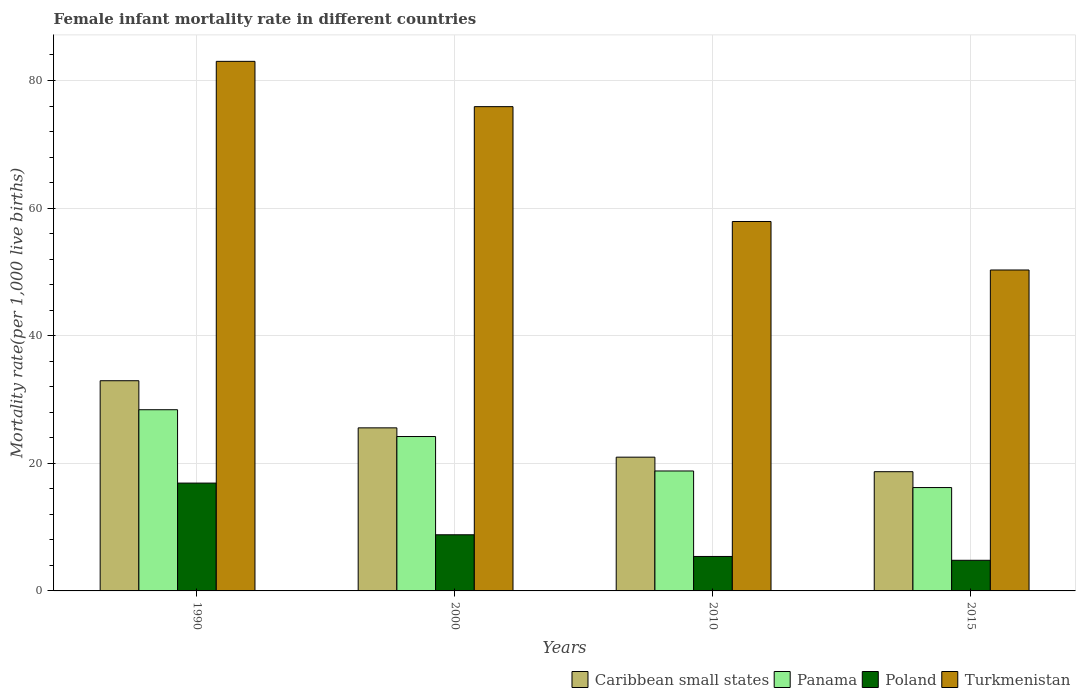How many groups of bars are there?
Offer a terse response. 4. Are the number of bars per tick equal to the number of legend labels?
Give a very brief answer. Yes. Are the number of bars on each tick of the X-axis equal?
Ensure brevity in your answer.  Yes. How many bars are there on the 4th tick from the left?
Your response must be concise. 4. How many bars are there on the 3rd tick from the right?
Provide a short and direct response. 4. What is the female infant mortality rate in Caribbean small states in 2010?
Your answer should be compact. 20.96. Across all years, what is the maximum female infant mortality rate in Caribbean small states?
Your response must be concise. 32.95. Across all years, what is the minimum female infant mortality rate in Caribbean small states?
Give a very brief answer. 18.69. In which year was the female infant mortality rate in Caribbean small states maximum?
Make the answer very short. 1990. In which year was the female infant mortality rate in Panama minimum?
Give a very brief answer. 2015. What is the total female infant mortality rate in Panama in the graph?
Provide a short and direct response. 87.6. What is the difference between the female infant mortality rate in Poland in 1990 and that in 2010?
Give a very brief answer. 11.5. What is the difference between the female infant mortality rate in Turkmenistan in 2010 and the female infant mortality rate in Caribbean small states in 2015?
Make the answer very short. 39.21. What is the average female infant mortality rate in Poland per year?
Provide a succinct answer. 8.97. In the year 2000, what is the difference between the female infant mortality rate in Panama and female infant mortality rate in Turkmenistan?
Offer a very short reply. -51.7. What is the ratio of the female infant mortality rate in Caribbean small states in 2000 to that in 2010?
Your answer should be compact. 1.22. What is the difference between the highest and the second highest female infant mortality rate in Poland?
Your answer should be very brief. 8.1. What is the difference between the highest and the lowest female infant mortality rate in Turkmenistan?
Keep it short and to the point. 32.7. Is the sum of the female infant mortality rate in Caribbean small states in 1990 and 2015 greater than the maximum female infant mortality rate in Panama across all years?
Provide a short and direct response. Yes. Is it the case that in every year, the sum of the female infant mortality rate in Poland and female infant mortality rate in Panama is greater than the sum of female infant mortality rate in Turkmenistan and female infant mortality rate in Caribbean small states?
Offer a very short reply. No. What does the 2nd bar from the left in 2000 represents?
Provide a succinct answer. Panama. Is it the case that in every year, the sum of the female infant mortality rate in Poland and female infant mortality rate in Turkmenistan is greater than the female infant mortality rate in Panama?
Your answer should be compact. Yes. How many bars are there?
Give a very brief answer. 16. How many years are there in the graph?
Your response must be concise. 4. Are the values on the major ticks of Y-axis written in scientific E-notation?
Provide a succinct answer. No. Does the graph contain grids?
Give a very brief answer. Yes. Where does the legend appear in the graph?
Give a very brief answer. Bottom right. How many legend labels are there?
Provide a short and direct response. 4. What is the title of the graph?
Give a very brief answer. Female infant mortality rate in different countries. Does "Lao PDR" appear as one of the legend labels in the graph?
Offer a terse response. No. What is the label or title of the Y-axis?
Keep it short and to the point. Mortality rate(per 1,0 live births). What is the Mortality rate(per 1,000 live births) in Caribbean small states in 1990?
Your response must be concise. 32.95. What is the Mortality rate(per 1,000 live births) in Panama in 1990?
Your answer should be compact. 28.4. What is the Mortality rate(per 1,000 live births) in Caribbean small states in 2000?
Make the answer very short. 25.56. What is the Mortality rate(per 1,000 live births) in Panama in 2000?
Give a very brief answer. 24.2. What is the Mortality rate(per 1,000 live births) in Turkmenistan in 2000?
Offer a very short reply. 75.9. What is the Mortality rate(per 1,000 live births) of Caribbean small states in 2010?
Provide a succinct answer. 20.96. What is the Mortality rate(per 1,000 live births) in Poland in 2010?
Ensure brevity in your answer.  5.4. What is the Mortality rate(per 1,000 live births) of Turkmenistan in 2010?
Offer a terse response. 57.9. What is the Mortality rate(per 1,000 live births) of Caribbean small states in 2015?
Ensure brevity in your answer.  18.69. What is the Mortality rate(per 1,000 live births) of Poland in 2015?
Ensure brevity in your answer.  4.8. What is the Mortality rate(per 1,000 live births) in Turkmenistan in 2015?
Ensure brevity in your answer.  50.3. Across all years, what is the maximum Mortality rate(per 1,000 live births) of Caribbean small states?
Give a very brief answer. 32.95. Across all years, what is the maximum Mortality rate(per 1,000 live births) in Panama?
Your response must be concise. 28.4. Across all years, what is the maximum Mortality rate(per 1,000 live births) of Poland?
Ensure brevity in your answer.  16.9. Across all years, what is the maximum Mortality rate(per 1,000 live births) of Turkmenistan?
Your answer should be compact. 83. Across all years, what is the minimum Mortality rate(per 1,000 live births) in Caribbean small states?
Keep it short and to the point. 18.69. Across all years, what is the minimum Mortality rate(per 1,000 live births) of Panama?
Offer a terse response. 16.2. Across all years, what is the minimum Mortality rate(per 1,000 live births) in Poland?
Your answer should be compact. 4.8. Across all years, what is the minimum Mortality rate(per 1,000 live births) of Turkmenistan?
Give a very brief answer. 50.3. What is the total Mortality rate(per 1,000 live births) in Caribbean small states in the graph?
Give a very brief answer. 98.15. What is the total Mortality rate(per 1,000 live births) of Panama in the graph?
Make the answer very short. 87.6. What is the total Mortality rate(per 1,000 live births) in Poland in the graph?
Give a very brief answer. 35.9. What is the total Mortality rate(per 1,000 live births) in Turkmenistan in the graph?
Ensure brevity in your answer.  267.1. What is the difference between the Mortality rate(per 1,000 live births) of Caribbean small states in 1990 and that in 2000?
Ensure brevity in your answer.  7.39. What is the difference between the Mortality rate(per 1,000 live births) in Poland in 1990 and that in 2000?
Provide a short and direct response. 8.1. What is the difference between the Mortality rate(per 1,000 live births) in Caribbean small states in 1990 and that in 2010?
Provide a short and direct response. 11.98. What is the difference between the Mortality rate(per 1,000 live births) in Turkmenistan in 1990 and that in 2010?
Your answer should be very brief. 25.1. What is the difference between the Mortality rate(per 1,000 live births) of Caribbean small states in 1990 and that in 2015?
Your answer should be compact. 14.26. What is the difference between the Mortality rate(per 1,000 live births) of Turkmenistan in 1990 and that in 2015?
Your response must be concise. 32.7. What is the difference between the Mortality rate(per 1,000 live births) in Caribbean small states in 2000 and that in 2010?
Your answer should be very brief. 4.59. What is the difference between the Mortality rate(per 1,000 live births) of Poland in 2000 and that in 2010?
Offer a terse response. 3.4. What is the difference between the Mortality rate(per 1,000 live births) of Turkmenistan in 2000 and that in 2010?
Give a very brief answer. 18. What is the difference between the Mortality rate(per 1,000 live births) of Caribbean small states in 2000 and that in 2015?
Give a very brief answer. 6.87. What is the difference between the Mortality rate(per 1,000 live births) of Panama in 2000 and that in 2015?
Give a very brief answer. 8. What is the difference between the Mortality rate(per 1,000 live births) of Poland in 2000 and that in 2015?
Provide a short and direct response. 4. What is the difference between the Mortality rate(per 1,000 live births) of Turkmenistan in 2000 and that in 2015?
Give a very brief answer. 25.6. What is the difference between the Mortality rate(per 1,000 live births) of Caribbean small states in 2010 and that in 2015?
Make the answer very short. 2.28. What is the difference between the Mortality rate(per 1,000 live births) of Panama in 2010 and that in 2015?
Your answer should be compact. 2.6. What is the difference between the Mortality rate(per 1,000 live births) of Poland in 2010 and that in 2015?
Ensure brevity in your answer.  0.6. What is the difference between the Mortality rate(per 1,000 live births) in Caribbean small states in 1990 and the Mortality rate(per 1,000 live births) in Panama in 2000?
Provide a short and direct response. 8.75. What is the difference between the Mortality rate(per 1,000 live births) in Caribbean small states in 1990 and the Mortality rate(per 1,000 live births) in Poland in 2000?
Offer a very short reply. 24.15. What is the difference between the Mortality rate(per 1,000 live births) in Caribbean small states in 1990 and the Mortality rate(per 1,000 live births) in Turkmenistan in 2000?
Offer a very short reply. -42.95. What is the difference between the Mortality rate(per 1,000 live births) in Panama in 1990 and the Mortality rate(per 1,000 live births) in Poland in 2000?
Offer a very short reply. 19.6. What is the difference between the Mortality rate(per 1,000 live births) of Panama in 1990 and the Mortality rate(per 1,000 live births) of Turkmenistan in 2000?
Ensure brevity in your answer.  -47.5. What is the difference between the Mortality rate(per 1,000 live births) of Poland in 1990 and the Mortality rate(per 1,000 live births) of Turkmenistan in 2000?
Offer a very short reply. -59. What is the difference between the Mortality rate(per 1,000 live births) of Caribbean small states in 1990 and the Mortality rate(per 1,000 live births) of Panama in 2010?
Ensure brevity in your answer.  14.15. What is the difference between the Mortality rate(per 1,000 live births) of Caribbean small states in 1990 and the Mortality rate(per 1,000 live births) of Poland in 2010?
Offer a terse response. 27.55. What is the difference between the Mortality rate(per 1,000 live births) of Caribbean small states in 1990 and the Mortality rate(per 1,000 live births) of Turkmenistan in 2010?
Your answer should be very brief. -24.95. What is the difference between the Mortality rate(per 1,000 live births) in Panama in 1990 and the Mortality rate(per 1,000 live births) in Poland in 2010?
Offer a very short reply. 23. What is the difference between the Mortality rate(per 1,000 live births) of Panama in 1990 and the Mortality rate(per 1,000 live births) of Turkmenistan in 2010?
Your answer should be compact. -29.5. What is the difference between the Mortality rate(per 1,000 live births) of Poland in 1990 and the Mortality rate(per 1,000 live births) of Turkmenistan in 2010?
Ensure brevity in your answer.  -41. What is the difference between the Mortality rate(per 1,000 live births) in Caribbean small states in 1990 and the Mortality rate(per 1,000 live births) in Panama in 2015?
Offer a very short reply. 16.75. What is the difference between the Mortality rate(per 1,000 live births) in Caribbean small states in 1990 and the Mortality rate(per 1,000 live births) in Poland in 2015?
Provide a succinct answer. 28.15. What is the difference between the Mortality rate(per 1,000 live births) of Caribbean small states in 1990 and the Mortality rate(per 1,000 live births) of Turkmenistan in 2015?
Your answer should be compact. -17.35. What is the difference between the Mortality rate(per 1,000 live births) of Panama in 1990 and the Mortality rate(per 1,000 live births) of Poland in 2015?
Keep it short and to the point. 23.6. What is the difference between the Mortality rate(per 1,000 live births) in Panama in 1990 and the Mortality rate(per 1,000 live births) in Turkmenistan in 2015?
Your response must be concise. -21.9. What is the difference between the Mortality rate(per 1,000 live births) in Poland in 1990 and the Mortality rate(per 1,000 live births) in Turkmenistan in 2015?
Your response must be concise. -33.4. What is the difference between the Mortality rate(per 1,000 live births) of Caribbean small states in 2000 and the Mortality rate(per 1,000 live births) of Panama in 2010?
Ensure brevity in your answer.  6.76. What is the difference between the Mortality rate(per 1,000 live births) in Caribbean small states in 2000 and the Mortality rate(per 1,000 live births) in Poland in 2010?
Your response must be concise. 20.16. What is the difference between the Mortality rate(per 1,000 live births) in Caribbean small states in 2000 and the Mortality rate(per 1,000 live births) in Turkmenistan in 2010?
Keep it short and to the point. -32.34. What is the difference between the Mortality rate(per 1,000 live births) in Panama in 2000 and the Mortality rate(per 1,000 live births) in Poland in 2010?
Give a very brief answer. 18.8. What is the difference between the Mortality rate(per 1,000 live births) in Panama in 2000 and the Mortality rate(per 1,000 live births) in Turkmenistan in 2010?
Make the answer very short. -33.7. What is the difference between the Mortality rate(per 1,000 live births) in Poland in 2000 and the Mortality rate(per 1,000 live births) in Turkmenistan in 2010?
Ensure brevity in your answer.  -49.1. What is the difference between the Mortality rate(per 1,000 live births) in Caribbean small states in 2000 and the Mortality rate(per 1,000 live births) in Panama in 2015?
Your answer should be compact. 9.36. What is the difference between the Mortality rate(per 1,000 live births) of Caribbean small states in 2000 and the Mortality rate(per 1,000 live births) of Poland in 2015?
Make the answer very short. 20.76. What is the difference between the Mortality rate(per 1,000 live births) in Caribbean small states in 2000 and the Mortality rate(per 1,000 live births) in Turkmenistan in 2015?
Make the answer very short. -24.74. What is the difference between the Mortality rate(per 1,000 live births) of Panama in 2000 and the Mortality rate(per 1,000 live births) of Turkmenistan in 2015?
Offer a terse response. -26.1. What is the difference between the Mortality rate(per 1,000 live births) in Poland in 2000 and the Mortality rate(per 1,000 live births) in Turkmenistan in 2015?
Make the answer very short. -41.5. What is the difference between the Mortality rate(per 1,000 live births) of Caribbean small states in 2010 and the Mortality rate(per 1,000 live births) of Panama in 2015?
Your answer should be very brief. 4.76. What is the difference between the Mortality rate(per 1,000 live births) in Caribbean small states in 2010 and the Mortality rate(per 1,000 live births) in Poland in 2015?
Give a very brief answer. 16.16. What is the difference between the Mortality rate(per 1,000 live births) of Caribbean small states in 2010 and the Mortality rate(per 1,000 live births) of Turkmenistan in 2015?
Your answer should be compact. -29.34. What is the difference between the Mortality rate(per 1,000 live births) in Panama in 2010 and the Mortality rate(per 1,000 live births) in Turkmenistan in 2015?
Make the answer very short. -31.5. What is the difference between the Mortality rate(per 1,000 live births) in Poland in 2010 and the Mortality rate(per 1,000 live births) in Turkmenistan in 2015?
Provide a short and direct response. -44.9. What is the average Mortality rate(per 1,000 live births) of Caribbean small states per year?
Make the answer very short. 24.54. What is the average Mortality rate(per 1,000 live births) of Panama per year?
Offer a very short reply. 21.9. What is the average Mortality rate(per 1,000 live births) of Poland per year?
Your answer should be compact. 8.97. What is the average Mortality rate(per 1,000 live births) in Turkmenistan per year?
Keep it short and to the point. 66.78. In the year 1990, what is the difference between the Mortality rate(per 1,000 live births) of Caribbean small states and Mortality rate(per 1,000 live births) of Panama?
Keep it short and to the point. 4.55. In the year 1990, what is the difference between the Mortality rate(per 1,000 live births) of Caribbean small states and Mortality rate(per 1,000 live births) of Poland?
Ensure brevity in your answer.  16.05. In the year 1990, what is the difference between the Mortality rate(per 1,000 live births) of Caribbean small states and Mortality rate(per 1,000 live births) of Turkmenistan?
Keep it short and to the point. -50.05. In the year 1990, what is the difference between the Mortality rate(per 1,000 live births) of Panama and Mortality rate(per 1,000 live births) of Turkmenistan?
Give a very brief answer. -54.6. In the year 1990, what is the difference between the Mortality rate(per 1,000 live births) of Poland and Mortality rate(per 1,000 live births) of Turkmenistan?
Your response must be concise. -66.1. In the year 2000, what is the difference between the Mortality rate(per 1,000 live births) in Caribbean small states and Mortality rate(per 1,000 live births) in Panama?
Offer a very short reply. 1.36. In the year 2000, what is the difference between the Mortality rate(per 1,000 live births) in Caribbean small states and Mortality rate(per 1,000 live births) in Poland?
Make the answer very short. 16.76. In the year 2000, what is the difference between the Mortality rate(per 1,000 live births) in Caribbean small states and Mortality rate(per 1,000 live births) in Turkmenistan?
Provide a short and direct response. -50.34. In the year 2000, what is the difference between the Mortality rate(per 1,000 live births) in Panama and Mortality rate(per 1,000 live births) in Turkmenistan?
Your response must be concise. -51.7. In the year 2000, what is the difference between the Mortality rate(per 1,000 live births) of Poland and Mortality rate(per 1,000 live births) of Turkmenistan?
Make the answer very short. -67.1. In the year 2010, what is the difference between the Mortality rate(per 1,000 live births) in Caribbean small states and Mortality rate(per 1,000 live births) in Panama?
Make the answer very short. 2.16. In the year 2010, what is the difference between the Mortality rate(per 1,000 live births) in Caribbean small states and Mortality rate(per 1,000 live births) in Poland?
Keep it short and to the point. 15.56. In the year 2010, what is the difference between the Mortality rate(per 1,000 live births) in Caribbean small states and Mortality rate(per 1,000 live births) in Turkmenistan?
Keep it short and to the point. -36.94. In the year 2010, what is the difference between the Mortality rate(per 1,000 live births) of Panama and Mortality rate(per 1,000 live births) of Turkmenistan?
Ensure brevity in your answer.  -39.1. In the year 2010, what is the difference between the Mortality rate(per 1,000 live births) in Poland and Mortality rate(per 1,000 live births) in Turkmenistan?
Offer a very short reply. -52.5. In the year 2015, what is the difference between the Mortality rate(per 1,000 live births) in Caribbean small states and Mortality rate(per 1,000 live births) in Panama?
Offer a very short reply. 2.49. In the year 2015, what is the difference between the Mortality rate(per 1,000 live births) in Caribbean small states and Mortality rate(per 1,000 live births) in Poland?
Provide a succinct answer. 13.89. In the year 2015, what is the difference between the Mortality rate(per 1,000 live births) of Caribbean small states and Mortality rate(per 1,000 live births) of Turkmenistan?
Your answer should be compact. -31.61. In the year 2015, what is the difference between the Mortality rate(per 1,000 live births) in Panama and Mortality rate(per 1,000 live births) in Poland?
Your response must be concise. 11.4. In the year 2015, what is the difference between the Mortality rate(per 1,000 live births) of Panama and Mortality rate(per 1,000 live births) of Turkmenistan?
Give a very brief answer. -34.1. In the year 2015, what is the difference between the Mortality rate(per 1,000 live births) in Poland and Mortality rate(per 1,000 live births) in Turkmenistan?
Provide a short and direct response. -45.5. What is the ratio of the Mortality rate(per 1,000 live births) in Caribbean small states in 1990 to that in 2000?
Provide a short and direct response. 1.29. What is the ratio of the Mortality rate(per 1,000 live births) of Panama in 1990 to that in 2000?
Offer a very short reply. 1.17. What is the ratio of the Mortality rate(per 1,000 live births) of Poland in 1990 to that in 2000?
Give a very brief answer. 1.92. What is the ratio of the Mortality rate(per 1,000 live births) of Turkmenistan in 1990 to that in 2000?
Your answer should be very brief. 1.09. What is the ratio of the Mortality rate(per 1,000 live births) in Caribbean small states in 1990 to that in 2010?
Your response must be concise. 1.57. What is the ratio of the Mortality rate(per 1,000 live births) in Panama in 1990 to that in 2010?
Your response must be concise. 1.51. What is the ratio of the Mortality rate(per 1,000 live births) in Poland in 1990 to that in 2010?
Ensure brevity in your answer.  3.13. What is the ratio of the Mortality rate(per 1,000 live births) in Turkmenistan in 1990 to that in 2010?
Your answer should be very brief. 1.43. What is the ratio of the Mortality rate(per 1,000 live births) of Caribbean small states in 1990 to that in 2015?
Your response must be concise. 1.76. What is the ratio of the Mortality rate(per 1,000 live births) in Panama in 1990 to that in 2015?
Your answer should be compact. 1.75. What is the ratio of the Mortality rate(per 1,000 live births) of Poland in 1990 to that in 2015?
Provide a succinct answer. 3.52. What is the ratio of the Mortality rate(per 1,000 live births) in Turkmenistan in 1990 to that in 2015?
Provide a short and direct response. 1.65. What is the ratio of the Mortality rate(per 1,000 live births) of Caribbean small states in 2000 to that in 2010?
Your response must be concise. 1.22. What is the ratio of the Mortality rate(per 1,000 live births) of Panama in 2000 to that in 2010?
Provide a succinct answer. 1.29. What is the ratio of the Mortality rate(per 1,000 live births) of Poland in 2000 to that in 2010?
Your answer should be compact. 1.63. What is the ratio of the Mortality rate(per 1,000 live births) in Turkmenistan in 2000 to that in 2010?
Your response must be concise. 1.31. What is the ratio of the Mortality rate(per 1,000 live births) of Caribbean small states in 2000 to that in 2015?
Make the answer very short. 1.37. What is the ratio of the Mortality rate(per 1,000 live births) of Panama in 2000 to that in 2015?
Provide a succinct answer. 1.49. What is the ratio of the Mortality rate(per 1,000 live births) in Poland in 2000 to that in 2015?
Ensure brevity in your answer.  1.83. What is the ratio of the Mortality rate(per 1,000 live births) in Turkmenistan in 2000 to that in 2015?
Your response must be concise. 1.51. What is the ratio of the Mortality rate(per 1,000 live births) of Caribbean small states in 2010 to that in 2015?
Offer a terse response. 1.12. What is the ratio of the Mortality rate(per 1,000 live births) of Panama in 2010 to that in 2015?
Give a very brief answer. 1.16. What is the ratio of the Mortality rate(per 1,000 live births) of Turkmenistan in 2010 to that in 2015?
Keep it short and to the point. 1.15. What is the difference between the highest and the second highest Mortality rate(per 1,000 live births) in Caribbean small states?
Provide a succinct answer. 7.39. What is the difference between the highest and the lowest Mortality rate(per 1,000 live births) of Caribbean small states?
Provide a short and direct response. 14.26. What is the difference between the highest and the lowest Mortality rate(per 1,000 live births) in Panama?
Make the answer very short. 12.2. What is the difference between the highest and the lowest Mortality rate(per 1,000 live births) in Turkmenistan?
Give a very brief answer. 32.7. 